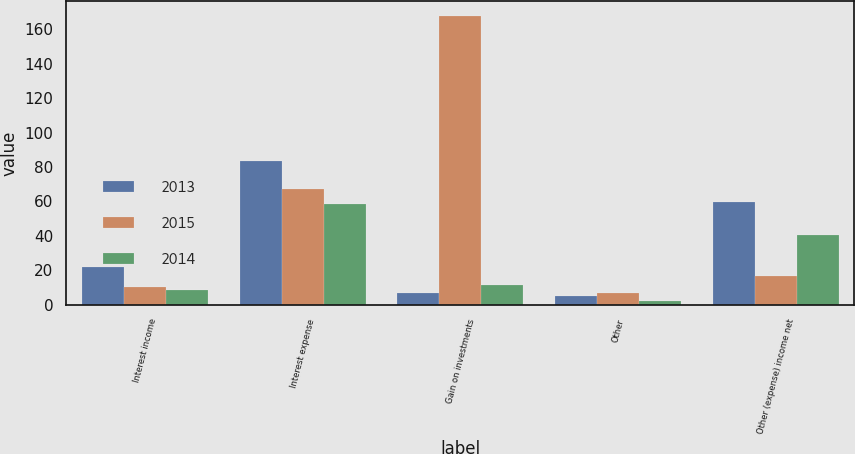Convert chart to OTSL. <chart><loc_0><loc_0><loc_500><loc_500><stacked_bar_chart><ecel><fcel>Interest income<fcel>Interest expense<fcel>Gain on investments<fcel>Other<fcel>Other (expense) income net<nl><fcel>2013<fcel>21.8<fcel>83.3<fcel>6.8<fcel>5.1<fcel>59.8<nl><fcel>2015<fcel>10<fcel>66.9<fcel>167.9<fcel>6.7<fcel>16.55<nl><fcel>2014<fcel>8.7<fcel>58.4<fcel>11.3<fcel>2<fcel>40.4<nl></chart> 